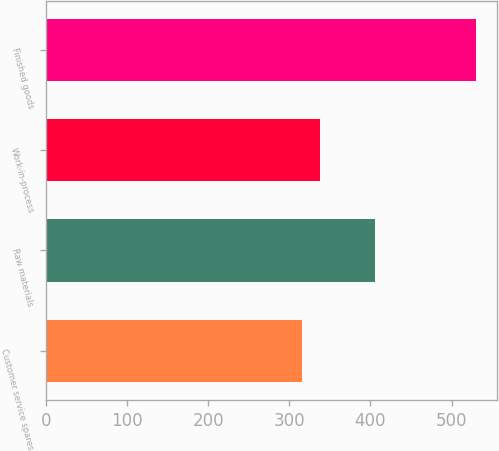<chart> <loc_0><loc_0><loc_500><loc_500><bar_chart><fcel>Customer service spares<fcel>Raw materials<fcel>Work-in-process<fcel>Finished goods<nl><fcel>316<fcel>405<fcel>337.4<fcel>530<nl></chart> 